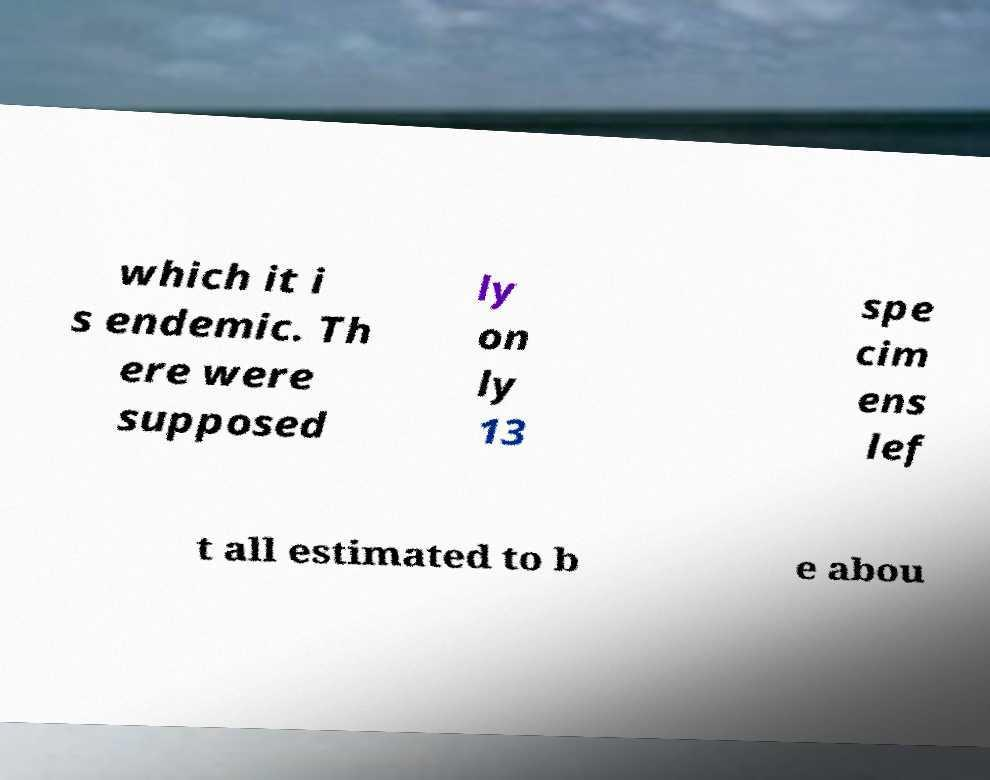Could you extract and type out the text from this image? which it i s endemic. Th ere were supposed ly on ly 13 spe cim ens lef t all estimated to b e abou 